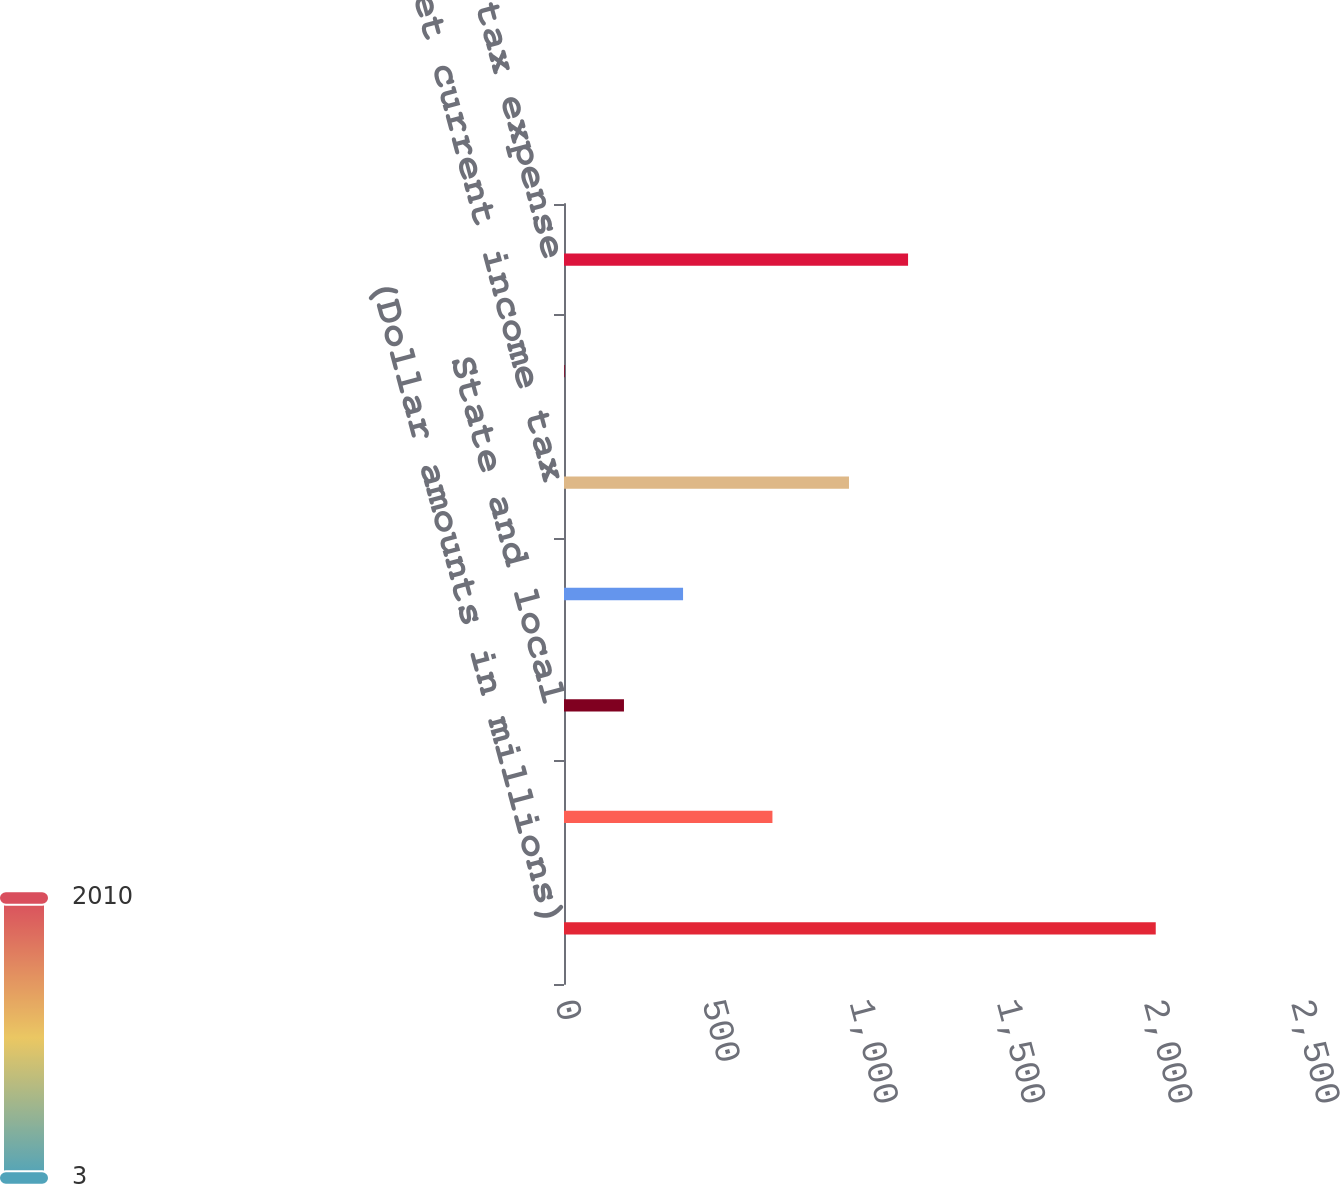Convert chart. <chart><loc_0><loc_0><loc_500><loc_500><bar_chart><fcel>(Dollar amounts in millions)<fcel>Federal<fcel>State and local<fcel>Foreign<fcel>total net current income tax<fcel>total net deferred income tax<fcel>total income tax expense<nl><fcel>2010<fcel>708<fcel>203.7<fcel>404.4<fcel>968<fcel>3<fcel>1168.7<nl></chart> 